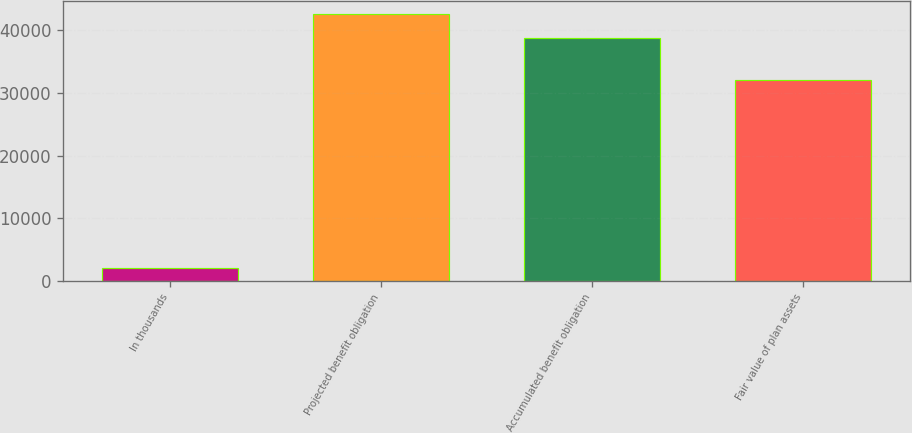<chart> <loc_0><loc_0><loc_500><loc_500><bar_chart><fcel>In thousands<fcel>Projected benefit obligation<fcel>Accumulated benefit obligation<fcel>Fair value of plan assets<nl><fcel>2018<fcel>42550.8<fcel>38805<fcel>31973<nl></chart> 